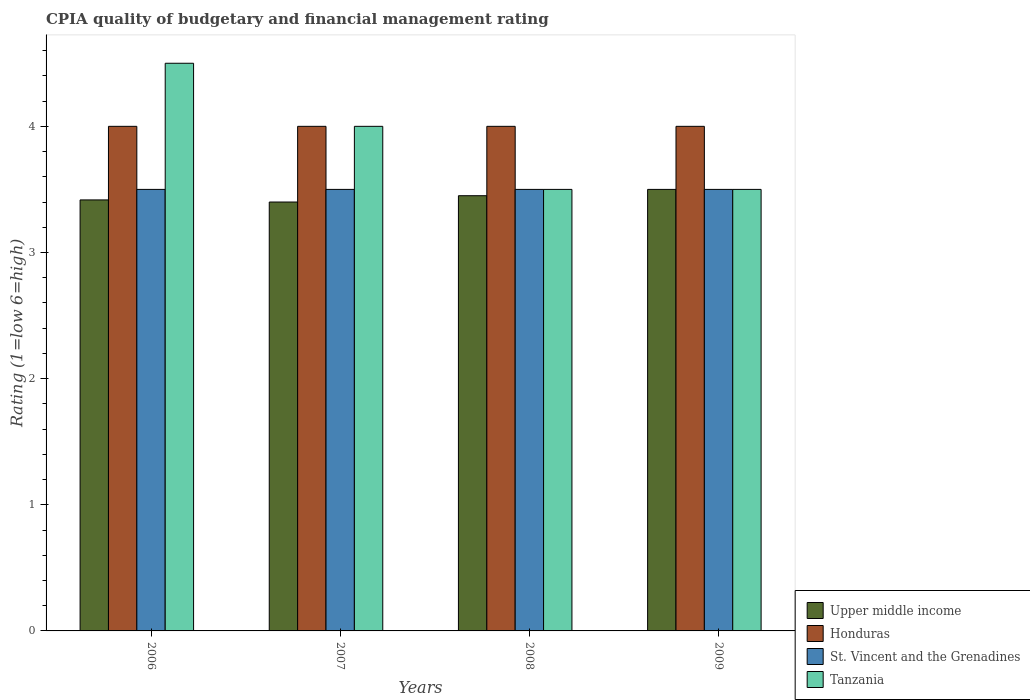How many different coloured bars are there?
Provide a short and direct response. 4. Are the number of bars per tick equal to the number of legend labels?
Offer a very short reply. Yes. Are the number of bars on each tick of the X-axis equal?
Keep it short and to the point. Yes. In how many cases, is the number of bars for a given year not equal to the number of legend labels?
Make the answer very short. 0. What is the CPIA rating in Upper middle income in 2006?
Offer a terse response. 3.42. In which year was the CPIA rating in Upper middle income maximum?
Give a very brief answer. 2009. In which year was the CPIA rating in Upper middle income minimum?
Keep it short and to the point. 2007. What is the total CPIA rating in Upper middle income in the graph?
Keep it short and to the point. 13.77. What is the difference between the CPIA rating in Upper middle income in 2006 and that in 2009?
Ensure brevity in your answer.  -0.08. What is the difference between the CPIA rating in St. Vincent and the Grenadines in 2007 and the CPIA rating in Tanzania in 2009?
Offer a very short reply. 0. What is the ratio of the CPIA rating in St. Vincent and the Grenadines in 2006 to that in 2008?
Offer a very short reply. 1. What is the difference between the highest and the second highest CPIA rating in Tanzania?
Ensure brevity in your answer.  0.5. In how many years, is the CPIA rating in Upper middle income greater than the average CPIA rating in Upper middle income taken over all years?
Your answer should be very brief. 2. What does the 1st bar from the left in 2008 represents?
Offer a very short reply. Upper middle income. What does the 2nd bar from the right in 2008 represents?
Provide a succinct answer. St. Vincent and the Grenadines. Are all the bars in the graph horizontal?
Offer a very short reply. No. What is the difference between two consecutive major ticks on the Y-axis?
Your answer should be very brief. 1. Are the values on the major ticks of Y-axis written in scientific E-notation?
Keep it short and to the point. No. Where does the legend appear in the graph?
Ensure brevity in your answer.  Bottom right. How many legend labels are there?
Your response must be concise. 4. What is the title of the graph?
Provide a succinct answer. CPIA quality of budgetary and financial management rating. What is the label or title of the Y-axis?
Make the answer very short. Rating (1=low 6=high). What is the Rating (1=low 6=high) in Upper middle income in 2006?
Offer a terse response. 3.42. What is the Rating (1=low 6=high) of Honduras in 2006?
Provide a succinct answer. 4. What is the Rating (1=low 6=high) of Upper middle income in 2007?
Make the answer very short. 3.4. What is the Rating (1=low 6=high) of Honduras in 2007?
Your response must be concise. 4. What is the Rating (1=low 6=high) in St. Vincent and the Grenadines in 2007?
Your answer should be compact. 3.5. What is the Rating (1=low 6=high) in Upper middle income in 2008?
Offer a terse response. 3.45. What is the Rating (1=low 6=high) in St. Vincent and the Grenadines in 2008?
Your answer should be very brief. 3.5. What is the Rating (1=low 6=high) of Tanzania in 2008?
Keep it short and to the point. 3.5. What is the Rating (1=low 6=high) in Upper middle income in 2009?
Your answer should be compact. 3.5. What is the Rating (1=low 6=high) in St. Vincent and the Grenadines in 2009?
Offer a very short reply. 3.5. What is the Rating (1=low 6=high) of Tanzania in 2009?
Provide a short and direct response. 3.5. Across all years, what is the maximum Rating (1=low 6=high) in Honduras?
Your response must be concise. 4. Across all years, what is the maximum Rating (1=low 6=high) in St. Vincent and the Grenadines?
Offer a terse response. 3.5. Across all years, what is the minimum Rating (1=low 6=high) in Upper middle income?
Provide a succinct answer. 3.4. Across all years, what is the minimum Rating (1=low 6=high) of St. Vincent and the Grenadines?
Provide a succinct answer. 3.5. What is the total Rating (1=low 6=high) of Upper middle income in the graph?
Keep it short and to the point. 13.77. What is the total Rating (1=low 6=high) of St. Vincent and the Grenadines in the graph?
Ensure brevity in your answer.  14. What is the difference between the Rating (1=low 6=high) of Upper middle income in 2006 and that in 2007?
Provide a succinct answer. 0.02. What is the difference between the Rating (1=low 6=high) in St. Vincent and the Grenadines in 2006 and that in 2007?
Keep it short and to the point. 0. What is the difference between the Rating (1=low 6=high) of Tanzania in 2006 and that in 2007?
Offer a very short reply. 0.5. What is the difference between the Rating (1=low 6=high) in Upper middle income in 2006 and that in 2008?
Provide a short and direct response. -0.03. What is the difference between the Rating (1=low 6=high) of Tanzania in 2006 and that in 2008?
Give a very brief answer. 1. What is the difference between the Rating (1=low 6=high) of Upper middle income in 2006 and that in 2009?
Your answer should be very brief. -0.08. What is the difference between the Rating (1=low 6=high) in St. Vincent and the Grenadines in 2006 and that in 2009?
Offer a terse response. 0. What is the difference between the Rating (1=low 6=high) in Upper middle income in 2007 and that in 2008?
Provide a short and direct response. -0.05. What is the difference between the Rating (1=low 6=high) of Honduras in 2007 and that in 2008?
Keep it short and to the point. 0. What is the difference between the Rating (1=low 6=high) in St. Vincent and the Grenadines in 2007 and that in 2008?
Make the answer very short. 0. What is the difference between the Rating (1=low 6=high) of Tanzania in 2007 and that in 2008?
Your response must be concise. 0.5. What is the difference between the Rating (1=low 6=high) in Upper middle income in 2007 and that in 2009?
Ensure brevity in your answer.  -0.1. What is the difference between the Rating (1=low 6=high) in Honduras in 2007 and that in 2009?
Your response must be concise. 0. What is the difference between the Rating (1=low 6=high) of Tanzania in 2008 and that in 2009?
Your answer should be compact. 0. What is the difference between the Rating (1=low 6=high) in Upper middle income in 2006 and the Rating (1=low 6=high) in Honduras in 2007?
Provide a short and direct response. -0.58. What is the difference between the Rating (1=low 6=high) in Upper middle income in 2006 and the Rating (1=low 6=high) in St. Vincent and the Grenadines in 2007?
Make the answer very short. -0.08. What is the difference between the Rating (1=low 6=high) of Upper middle income in 2006 and the Rating (1=low 6=high) of Tanzania in 2007?
Your answer should be compact. -0.58. What is the difference between the Rating (1=low 6=high) in Upper middle income in 2006 and the Rating (1=low 6=high) in Honduras in 2008?
Make the answer very short. -0.58. What is the difference between the Rating (1=low 6=high) in Upper middle income in 2006 and the Rating (1=low 6=high) in St. Vincent and the Grenadines in 2008?
Your answer should be compact. -0.08. What is the difference between the Rating (1=low 6=high) in Upper middle income in 2006 and the Rating (1=low 6=high) in Tanzania in 2008?
Offer a terse response. -0.08. What is the difference between the Rating (1=low 6=high) of St. Vincent and the Grenadines in 2006 and the Rating (1=low 6=high) of Tanzania in 2008?
Keep it short and to the point. 0. What is the difference between the Rating (1=low 6=high) of Upper middle income in 2006 and the Rating (1=low 6=high) of Honduras in 2009?
Provide a short and direct response. -0.58. What is the difference between the Rating (1=low 6=high) in Upper middle income in 2006 and the Rating (1=low 6=high) in St. Vincent and the Grenadines in 2009?
Your response must be concise. -0.08. What is the difference between the Rating (1=low 6=high) in Upper middle income in 2006 and the Rating (1=low 6=high) in Tanzania in 2009?
Your answer should be compact. -0.08. What is the difference between the Rating (1=low 6=high) of Honduras in 2006 and the Rating (1=low 6=high) of St. Vincent and the Grenadines in 2009?
Ensure brevity in your answer.  0.5. What is the difference between the Rating (1=low 6=high) of Upper middle income in 2007 and the Rating (1=low 6=high) of Honduras in 2008?
Give a very brief answer. -0.6. What is the difference between the Rating (1=low 6=high) of Upper middle income in 2007 and the Rating (1=low 6=high) of Tanzania in 2008?
Provide a succinct answer. -0.1. What is the difference between the Rating (1=low 6=high) in Honduras in 2007 and the Rating (1=low 6=high) in St. Vincent and the Grenadines in 2008?
Your answer should be compact. 0.5. What is the difference between the Rating (1=low 6=high) in Upper middle income in 2007 and the Rating (1=low 6=high) in Honduras in 2009?
Ensure brevity in your answer.  -0.6. What is the difference between the Rating (1=low 6=high) of Upper middle income in 2007 and the Rating (1=low 6=high) of St. Vincent and the Grenadines in 2009?
Offer a terse response. -0.1. What is the difference between the Rating (1=low 6=high) of Honduras in 2007 and the Rating (1=low 6=high) of St. Vincent and the Grenadines in 2009?
Your response must be concise. 0.5. What is the difference between the Rating (1=low 6=high) in Honduras in 2007 and the Rating (1=low 6=high) in Tanzania in 2009?
Offer a terse response. 0.5. What is the difference between the Rating (1=low 6=high) of Upper middle income in 2008 and the Rating (1=low 6=high) of Honduras in 2009?
Your answer should be compact. -0.55. What is the difference between the Rating (1=low 6=high) in Upper middle income in 2008 and the Rating (1=low 6=high) in St. Vincent and the Grenadines in 2009?
Make the answer very short. -0.05. What is the difference between the Rating (1=low 6=high) of Upper middle income in 2008 and the Rating (1=low 6=high) of Tanzania in 2009?
Make the answer very short. -0.05. What is the difference between the Rating (1=low 6=high) of Honduras in 2008 and the Rating (1=low 6=high) of St. Vincent and the Grenadines in 2009?
Your answer should be very brief. 0.5. What is the difference between the Rating (1=low 6=high) of Honduras in 2008 and the Rating (1=low 6=high) of Tanzania in 2009?
Your answer should be compact. 0.5. What is the average Rating (1=low 6=high) in Upper middle income per year?
Make the answer very short. 3.44. What is the average Rating (1=low 6=high) of Honduras per year?
Provide a succinct answer. 4. What is the average Rating (1=low 6=high) in St. Vincent and the Grenadines per year?
Provide a succinct answer. 3.5. What is the average Rating (1=low 6=high) in Tanzania per year?
Keep it short and to the point. 3.88. In the year 2006, what is the difference between the Rating (1=low 6=high) in Upper middle income and Rating (1=low 6=high) in Honduras?
Offer a terse response. -0.58. In the year 2006, what is the difference between the Rating (1=low 6=high) in Upper middle income and Rating (1=low 6=high) in St. Vincent and the Grenadines?
Your answer should be very brief. -0.08. In the year 2006, what is the difference between the Rating (1=low 6=high) of Upper middle income and Rating (1=low 6=high) of Tanzania?
Your answer should be compact. -1.08. In the year 2006, what is the difference between the Rating (1=low 6=high) in Honduras and Rating (1=low 6=high) in Tanzania?
Provide a succinct answer. -0.5. In the year 2006, what is the difference between the Rating (1=low 6=high) of St. Vincent and the Grenadines and Rating (1=low 6=high) of Tanzania?
Provide a short and direct response. -1. In the year 2007, what is the difference between the Rating (1=low 6=high) of Honduras and Rating (1=low 6=high) of St. Vincent and the Grenadines?
Your answer should be very brief. 0.5. In the year 2007, what is the difference between the Rating (1=low 6=high) of St. Vincent and the Grenadines and Rating (1=low 6=high) of Tanzania?
Provide a succinct answer. -0.5. In the year 2008, what is the difference between the Rating (1=low 6=high) in Upper middle income and Rating (1=low 6=high) in Honduras?
Provide a succinct answer. -0.55. In the year 2008, what is the difference between the Rating (1=low 6=high) in Honduras and Rating (1=low 6=high) in Tanzania?
Your answer should be very brief. 0.5. In the year 2008, what is the difference between the Rating (1=low 6=high) of St. Vincent and the Grenadines and Rating (1=low 6=high) of Tanzania?
Ensure brevity in your answer.  0. In the year 2009, what is the difference between the Rating (1=low 6=high) in Upper middle income and Rating (1=low 6=high) in Honduras?
Give a very brief answer. -0.5. In the year 2009, what is the difference between the Rating (1=low 6=high) of Upper middle income and Rating (1=low 6=high) of St. Vincent and the Grenadines?
Your response must be concise. 0. In the year 2009, what is the difference between the Rating (1=low 6=high) of Upper middle income and Rating (1=low 6=high) of Tanzania?
Give a very brief answer. 0. In the year 2009, what is the difference between the Rating (1=low 6=high) of Honduras and Rating (1=low 6=high) of St. Vincent and the Grenadines?
Provide a short and direct response. 0.5. What is the ratio of the Rating (1=low 6=high) in St. Vincent and the Grenadines in 2006 to that in 2007?
Ensure brevity in your answer.  1. What is the ratio of the Rating (1=low 6=high) in Tanzania in 2006 to that in 2007?
Offer a very short reply. 1.12. What is the ratio of the Rating (1=low 6=high) in Upper middle income in 2006 to that in 2008?
Your answer should be compact. 0.99. What is the ratio of the Rating (1=low 6=high) of Honduras in 2006 to that in 2008?
Provide a short and direct response. 1. What is the ratio of the Rating (1=low 6=high) in Upper middle income in 2006 to that in 2009?
Your answer should be very brief. 0.98. What is the ratio of the Rating (1=low 6=high) of Upper middle income in 2007 to that in 2008?
Offer a very short reply. 0.99. What is the ratio of the Rating (1=low 6=high) of St. Vincent and the Grenadines in 2007 to that in 2008?
Offer a terse response. 1. What is the ratio of the Rating (1=low 6=high) in Tanzania in 2007 to that in 2008?
Your answer should be compact. 1.14. What is the ratio of the Rating (1=low 6=high) in Upper middle income in 2007 to that in 2009?
Make the answer very short. 0.97. What is the ratio of the Rating (1=low 6=high) of Honduras in 2007 to that in 2009?
Give a very brief answer. 1. What is the ratio of the Rating (1=low 6=high) of Upper middle income in 2008 to that in 2009?
Provide a succinct answer. 0.99. What is the ratio of the Rating (1=low 6=high) of St. Vincent and the Grenadines in 2008 to that in 2009?
Make the answer very short. 1. What is the difference between the highest and the second highest Rating (1=low 6=high) in Upper middle income?
Provide a short and direct response. 0.05. What is the difference between the highest and the second highest Rating (1=low 6=high) in Tanzania?
Ensure brevity in your answer.  0.5. What is the difference between the highest and the lowest Rating (1=low 6=high) of Honduras?
Give a very brief answer. 0. What is the difference between the highest and the lowest Rating (1=low 6=high) of St. Vincent and the Grenadines?
Your response must be concise. 0. What is the difference between the highest and the lowest Rating (1=low 6=high) in Tanzania?
Provide a succinct answer. 1. 